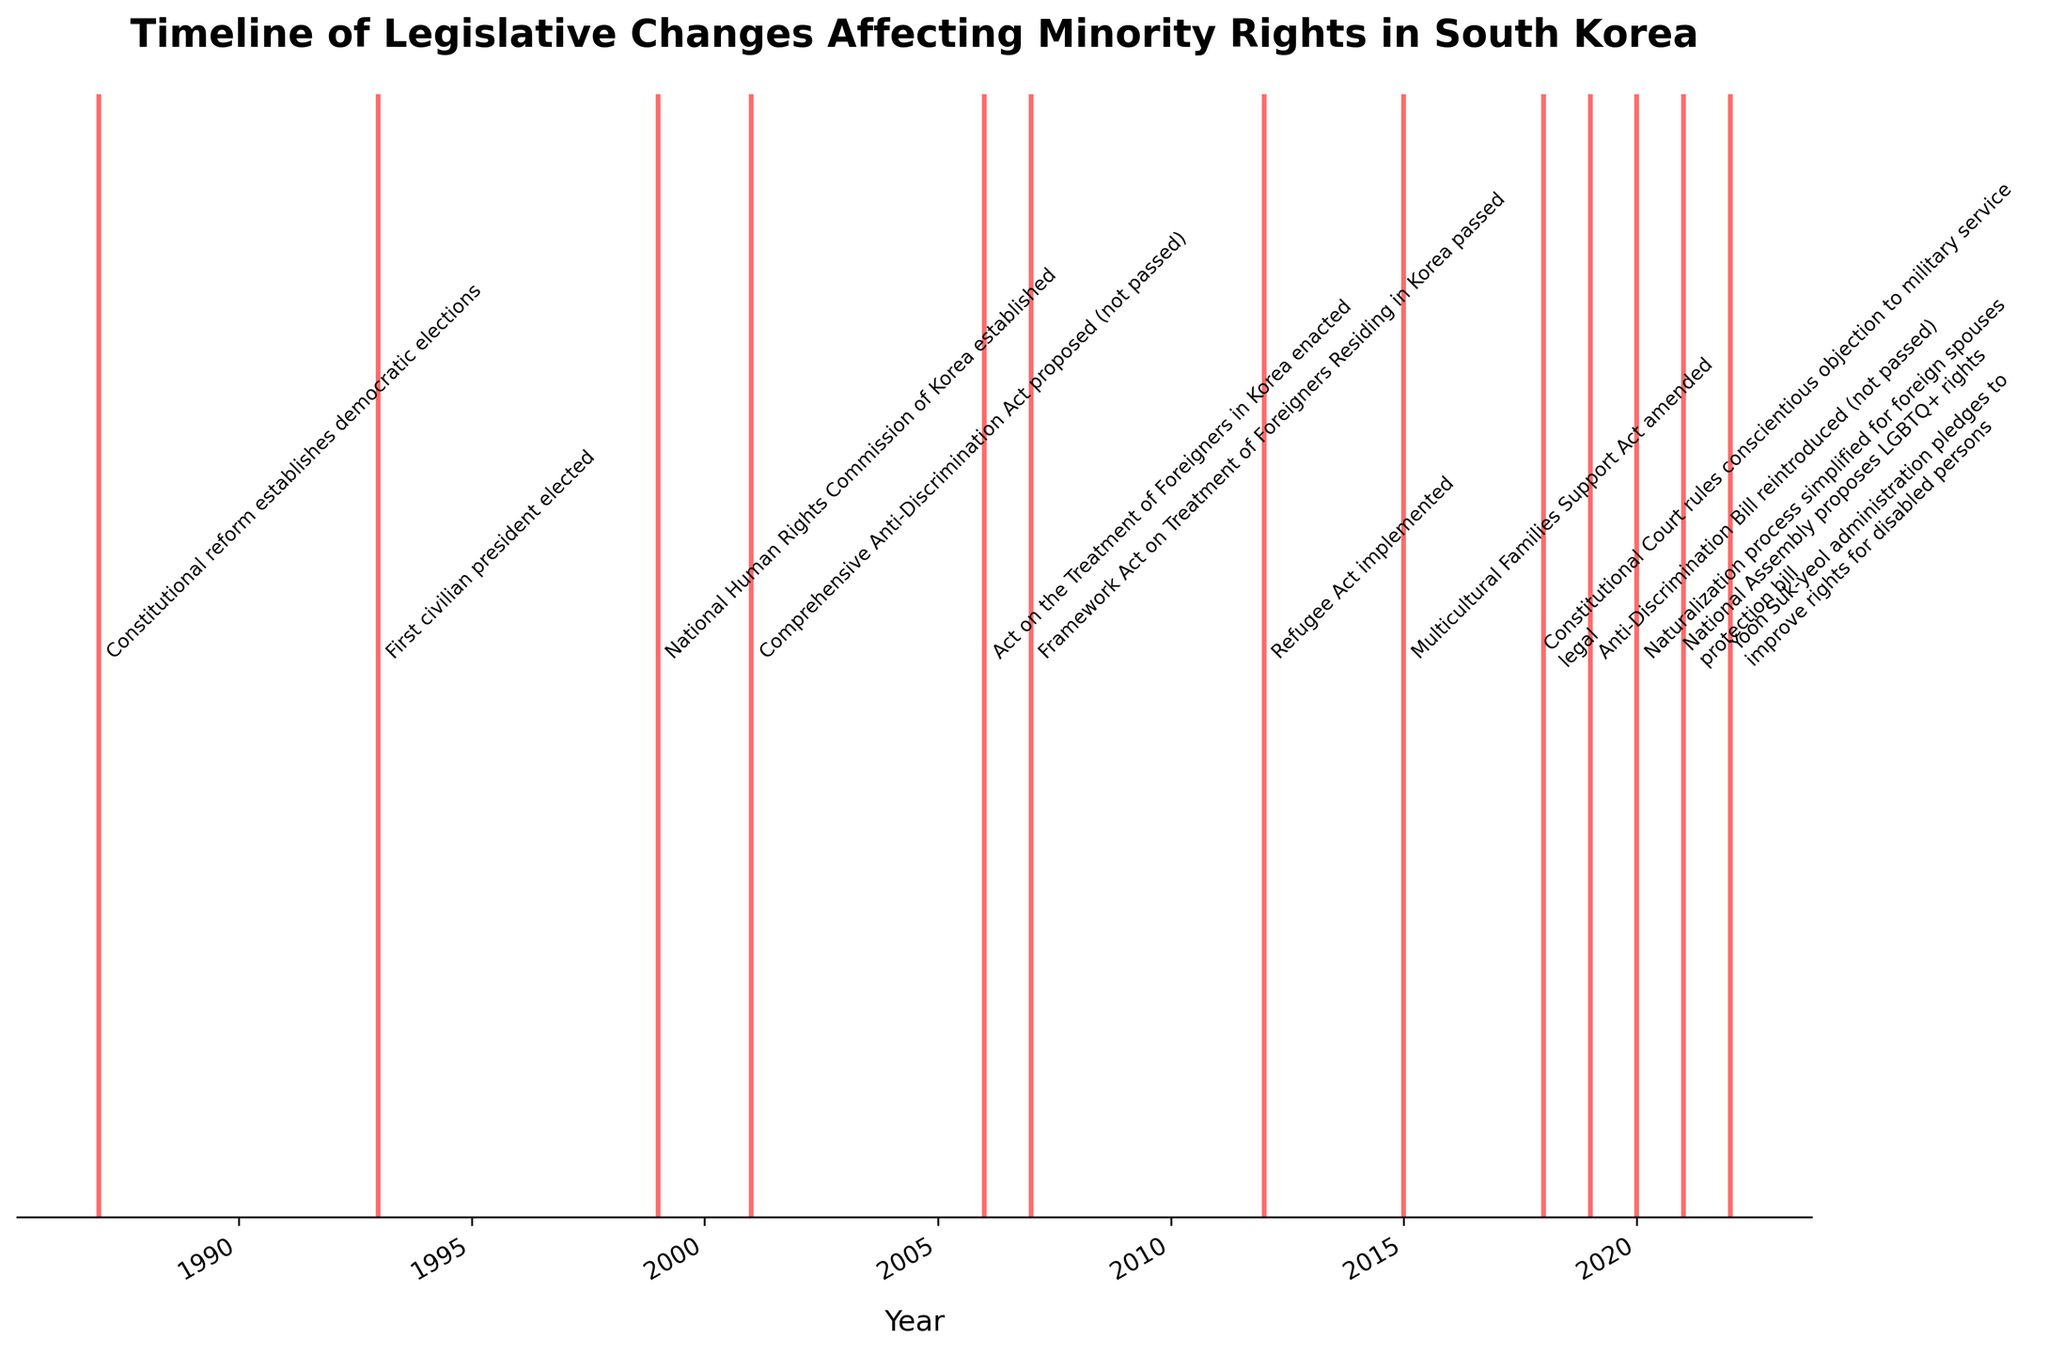What is the title of the figure? The title is usually displayed at the top of the figure. Reading the text in that position will reveal the title. In this case, it says: "Timeline of Legislative Changes Affecting Minority Rights in South Korea".
Answer: Timeline of Legislative Changes Affecting Minority Rights in South Korea What color are the events plotted in? Observing the color of the vertical lines representing the events in the plot, we can see they are a bright red color.
Answer: Red How many legislative events are listed on the timeline? Count each vertical line in the plot to determine the number of legislative events. In this case, there are 13 events.
Answer: 13 When was the first comprehensive anti-discrimination act proposed? Look for the event labeled as "Comprehensive Anti-Discrimination Act proposed" and note the year on the x-axis directly below it. It is marked at 2001.
Answer: 2001 Which events occurred after 2010? Identify the events plotted to the right of the 2010 mark on the x-axis. These events are: "Refugee Act implemented (2012)", "Multicultural Families Support Act amended (2015)", "Constitutional Court rules conscientious objection to military service legal (2018)", "Anti-Discrimination Bill reintroduced (2019)", "Naturalization process simplified for foreign spouses (2020)", "National Assembly proposes LGBTQ+ rights protection bill (2021)", and "Yoon Suk-yeol administration pledges to improve rights for disabled persons (2022)".
Answer: Refugee Act implemented (2012), Multicultural Families Support Act amended (2015), Constitutional Court rules conscientious objection to military service legal (2018), Anti-Discrimination Bill reintroduced (2019), Naturalization process simplified for foreign spouses (2020), National Assembly proposes LGBTQ+ rights protection bill (2021), Yoon Suk-yeol administration pledges to improve rights for disabled persons (2022) In which year was the National Human Rights Commission of Korea established, and how many years after the first civilian president was elected did this occur? The National Human Rights Commission of Korea was established in 1999, as shown by the event labeled on the timeline. The first civilian president was elected in 1993. The difference between these years is 1999 - 1993 = 6 years.
Answer: 1999, 6 years Which event occurred most recently on the timeline? The most recent event will be the one plotted furthest to the right, labeled "Yoon Suk-yeol administration pledges to improve rights for disabled persons". This event occurred in 2022.
Answer: Yoon Suk-yeol administration pledges to improve rights for disabled persons, 2022 Compare the number of events related to foreigner rights versus those related to LGBTQ+ rights. Which has more events? Identify and count the events related to foreigner rights: "Act on the Treatment of Foreigners in Korea (2006)", "Framework Act on Treatment of Foreigners Residing in Korea (2007)", "Refugee Act implemented (2012)", and "Naturalization process simplified for foreign spouses (2020)"—total 4 events. For LGBTQ+ rights, there is only "National Assembly proposes LGBTQ+ rights protection bill (2021)"—total 1 event. Thus, foreigner rights have more events.
Answer: Foreigner rights Analyze the frequency of legislative events. Is there a trend of increasing or decreasing legislative events over time? Divide the timeline into segments (e.g., 1980s, 1990s, 2000s, 2010s) and count the events in each period. 1980s (1 event), 1990s (2 events), 2000s (4 events), 2010s (5 events), and 2020s (2 events so far). Observing this, we see an increasing trend until the 2010s, but it's too soon to judge for the 2020s.
Answer: Increasing until 2010s 